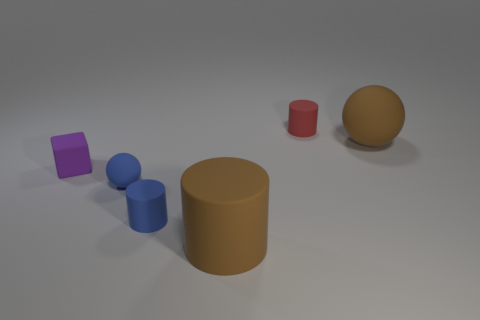Add 3 purple rubber blocks. How many objects exist? 9 Subtract all small cylinders. How many cylinders are left? 1 Add 4 large brown matte cylinders. How many large brown matte cylinders exist? 5 Subtract all brown spheres. How many spheres are left? 1 Subtract 1 blue balls. How many objects are left? 5 Subtract all balls. How many objects are left? 4 Subtract 1 spheres. How many spheres are left? 1 Subtract all green spheres. Subtract all blue blocks. How many spheres are left? 2 Subtract all blue cubes. How many red cylinders are left? 1 Subtract all brown balls. Subtract all purple matte blocks. How many objects are left? 4 